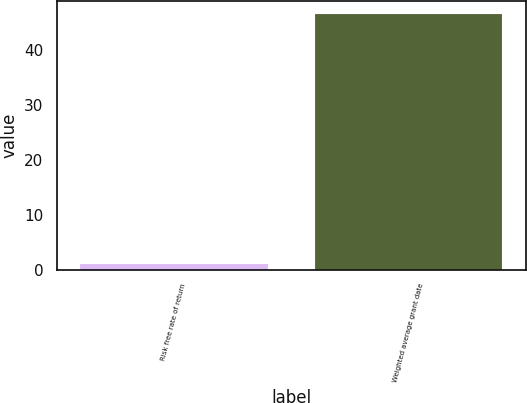Convert chart to OTSL. <chart><loc_0><loc_0><loc_500><loc_500><bar_chart><fcel>Risk free rate of return<fcel>Weighted average grant date<nl><fcel>1.01<fcel>46.54<nl></chart> 